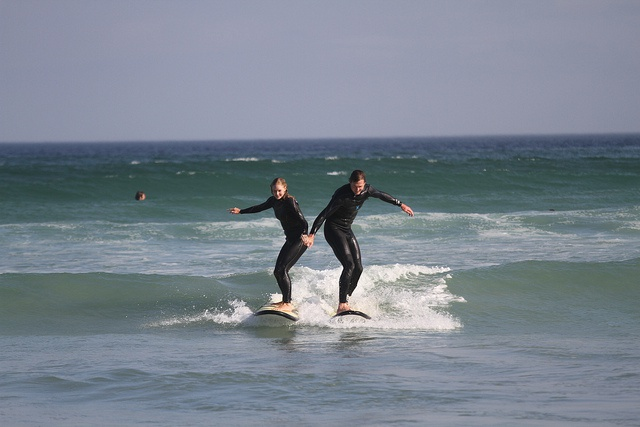Describe the objects in this image and their specific colors. I can see people in gray, black, darkgray, and lightgray tones, people in gray, black, brown, and maroon tones, surfboard in gray, black, beige, and darkgray tones, surfboard in gray, lightgray, black, and darkgray tones, and people in gray, black, brown, and maroon tones in this image. 